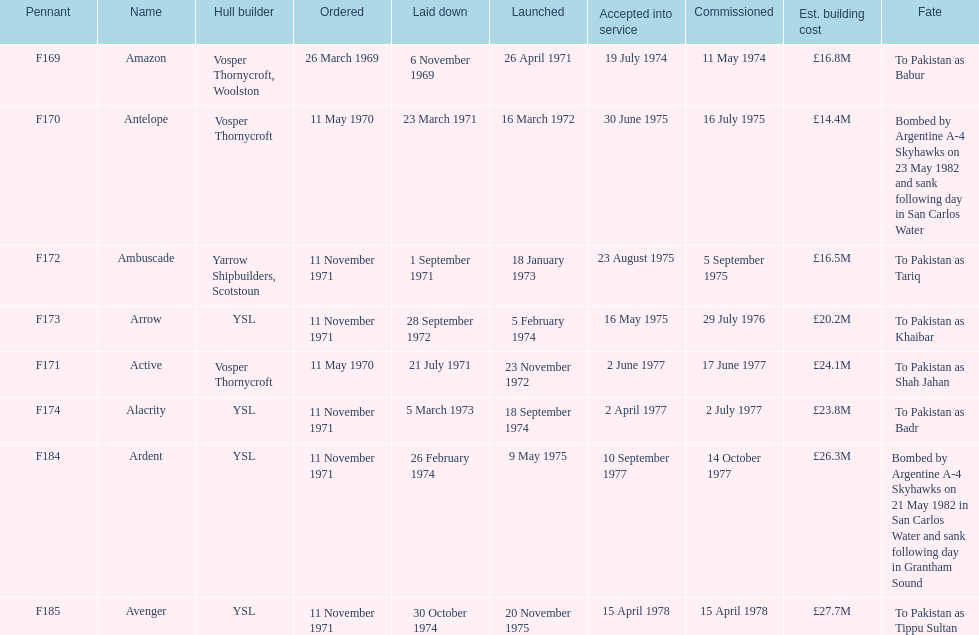What is the title of the vessel mentioned after ardent? Avenger. 